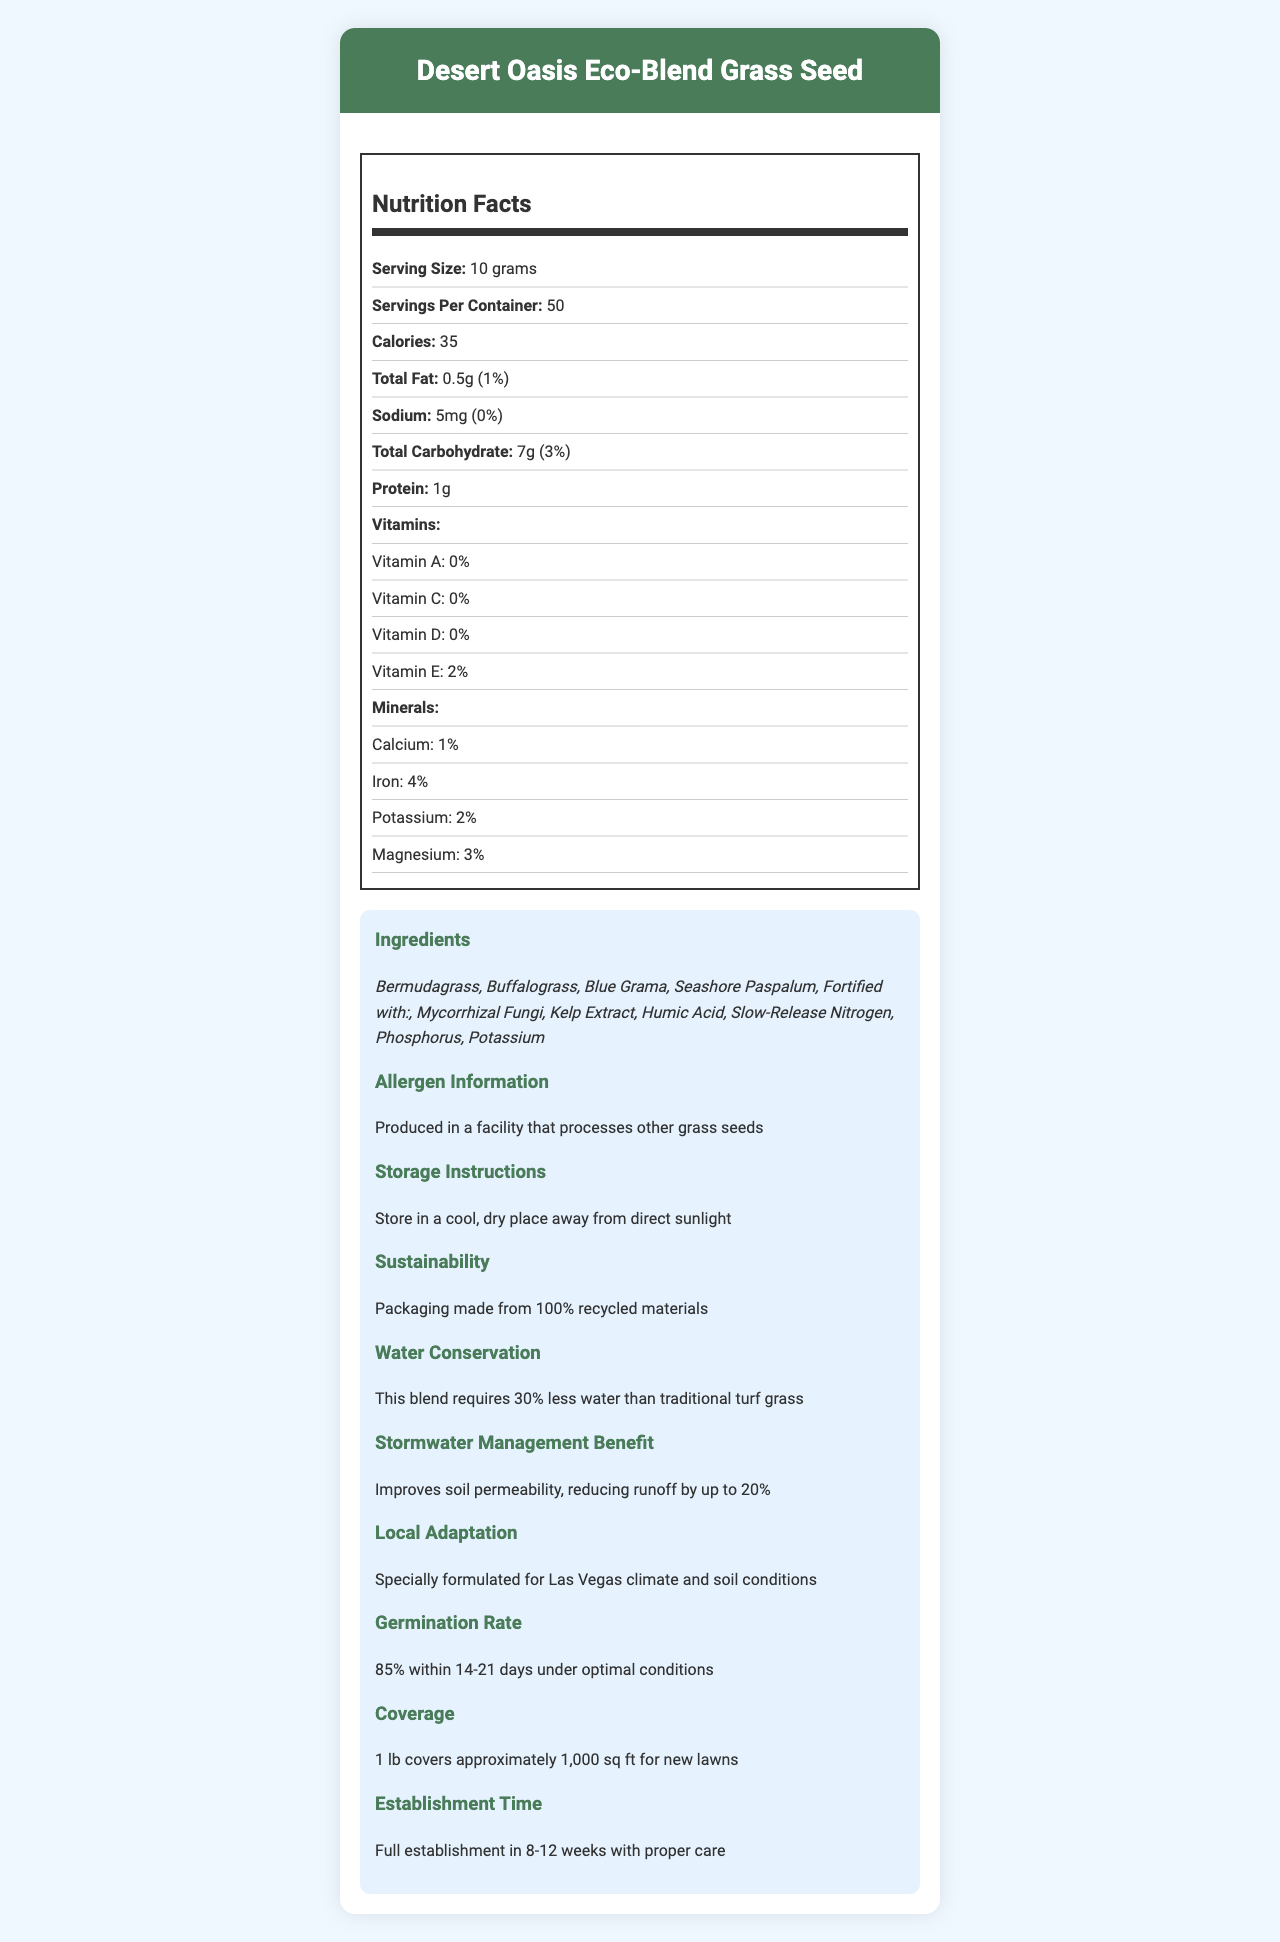what is the serving size? The document specifies that the serving size is 10 grams.
Answer: 10 grams how many servings are there per container? The document indicates there are 50 servings per container.
Answer: 50 how many calories are in one serving? The document lists that there are 35 calories per serving.
Answer: 35 what is the total fat content per serving? The document shows that the total fat content per serving is 0.5g.
Answer: 0.5g what is the sodium content per serving? The document states that the sodium content per serving is 5mg.
Answer: 5mg what are the ingredients in the grass seed blend? The document lists all the ingredients under the "Ingredients" section.
Answer: Bermudagrass, Buffalograss, Blue Grama, Seashore Paspalum, Mycorrhizal Fungi, Kelp Extract, Humic Acid, Slow-Release Nitrogen, Phosphorus, Potassium what is the daily value percentage of Iron per serving? The document states that the daily value of Iron per serving is 4%.
Answer: 4% what vitamins are included, and what are their daily values? A. Vitamin A - 0%, Vitamin C - 0%, Vitamin D - 0%, Vitamin E - 2% B. Vitamin A - 2%, Vitamin C - 2%, Vitamin D - 2%, Vitamin E - 4% C. Vitamin A - 1%, Vitamin C - 1%, Vitamin D - 1%, Vitamin E - 3% The document lists the vitamins and their daily values as: Vitamin A - 0%, Vitamin C - 0%, Vitamin D - 0%, Vitamin E - 2%.
Answer: A which of the following minerals has the highest daily value percentage per serving? (i) Calcium (ii) Magnesium (iii) Potassium (iv) Iron Iron has the highest daily value percentage per serving at 4%, compared to Calcium (1%), Magnesium (3%), and Potassium (2%).
Answer: iv is this product meant for increasing soil permeability? The document mentions that the product improves soil permeability, reducing runoff by up to 20%.
Answer: Yes does the packaging use recycled materials? The document states that the packaging is made from 100% recycled materials.
Answer: Yes what is the germination rate under optimal conditions? The document specifies a germination rate of 85% within 14-21 days under optimal conditions.
Answer: 85% within 14-21 days what additional benefits does this grass seed blend provide in terms of water conservation? The document mentions that the grass seed blend requires 30% less water compared to traditional turf grass.
Answer: This blend requires 30% less water than traditional turf grass how should this product be stored? The document advises storing the product in a cool, dry place away from direct sunlight.
Answer: Store in a cool, dry place away from direct sunlight summarize the main features and benefits of Desert Oasis Eco-Blend Grass Seed. The document highlights the grass seed's drought resistance, nutrient fortification, suitability for Las Vegas climate, sustainability, water conservation benefits, soil permeability improvements, high germination rate, and eco-friendly packaging.
Answer: The Desert Oasis Eco-Blend Grass Seed is a drought-resistant grass seed blend with fortified nutrients, suitable for the Las Vegas climate. It provides sustainable design benefits, requires 30% less water, and improves soil permeability, reducing runoff by up to 20%. It has a high germination rate of 85% within 14-21 days and is packaged using 100% recycled materials. what is the source of your data? The document does not provide information about the data source.
Answer: Cannot be determined 